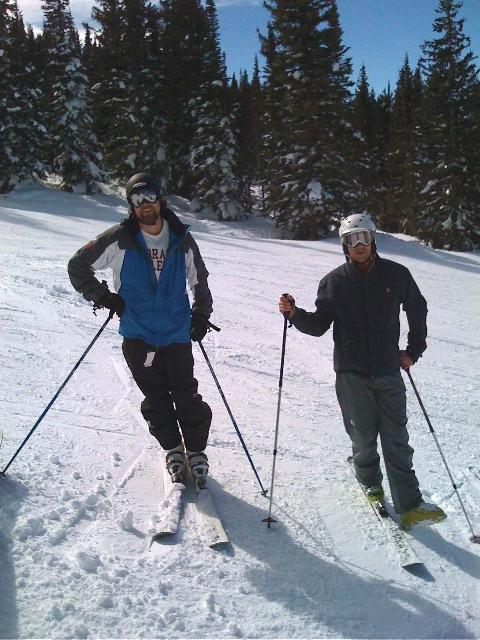How many people are holding ski poles? Please explain your reasoning. two. There are two people standing on the ski slope holding ski poles. 